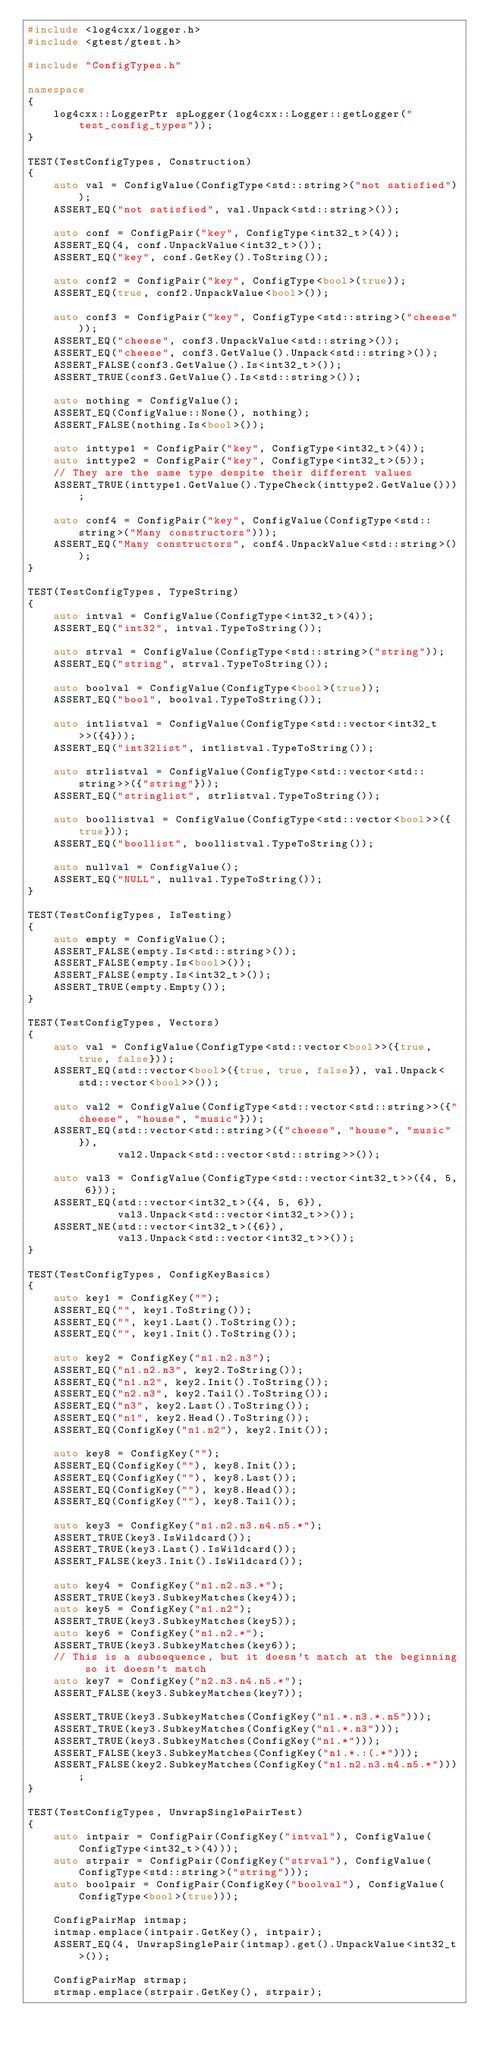<code> <loc_0><loc_0><loc_500><loc_500><_C++_>#include <log4cxx/logger.h>
#include <gtest/gtest.h>

#include "ConfigTypes.h"

namespace
{
    log4cxx::LoggerPtr spLogger(log4cxx::Logger::getLogger("test_config_types"));
}

TEST(TestConfigTypes, Construction)
{
    auto val = ConfigValue(ConfigType<std::string>("not satisfied"));
    ASSERT_EQ("not satisfied", val.Unpack<std::string>());

    auto conf = ConfigPair("key", ConfigType<int32_t>(4));
    ASSERT_EQ(4, conf.UnpackValue<int32_t>());
    ASSERT_EQ("key", conf.GetKey().ToString());

    auto conf2 = ConfigPair("key", ConfigType<bool>(true));
    ASSERT_EQ(true, conf2.UnpackValue<bool>());

    auto conf3 = ConfigPair("key", ConfigType<std::string>("cheese"));
    ASSERT_EQ("cheese", conf3.UnpackValue<std::string>());
    ASSERT_EQ("cheese", conf3.GetValue().Unpack<std::string>());
    ASSERT_FALSE(conf3.GetValue().Is<int32_t>());
    ASSERT_TRUE(conf3.GetValue().Is<std::string>());

    auto nothing = ConfigValue();
    ASSERT_EQ(ConfigValue::None(), nothing);
    ASSERT_FALSE(nothing.Is<bool>());

    auto inttype1 = ConfigPair("key", ConfigType<int32_t>(4));
    auto inttype2 = ConfigPair("key", ConfigType<int32_t>(5));
    // They are the same type despite their different values
    ASSERT_TRUE(inttype1.GetValue().TypeCheck(inttype2.GetValue()));

    auto conf4 = ConfigPair("key", ConfigValue(ConfigType<std::string>("Many constructors")));
    ASSERT_EQ("Many constructors", conf4.UnpackValue<std::string>());
}

TEST(TestConfigTypes, TypeString)
{
    auto intval = ConfigValue(ConfigType<int32_t>(4));
    ASSERT_EQ("int32", intval.TypeToString());

    auto strval = ConfigValue(ConfigType<std::string>("string"));
    ASSERT_EQ("string", strval.TypeToString());

    auto boolval = ConfigValue(ConfigType<bool>(true));
    ASSERT_EQ("bool", boolval.TypeToString());

    auto intlistval = ConfigValue(ConfigType<std::vector<int32_t>>({4}));
    ASSERT_EQ("int32list", intlistval.TypeToString());

    auto strlistval = ConfigValue(ConfigType<std::vector<std::string>>({"string"}));
    ASSERT_EQ("stringlist", strlistval.TypeToString());

    auto boollistval = ConfigValue(ConfigType<std::vector<bool>>({true}));
    ASSERT_EQ("boollist", boollistval.TypeToString());

    auto nullval = ConfigValue();
    ASSERT_EQ("NULL", nullval.TypeToString());
}

TEST(TestConfigTypes, IsTesting)
{
    auto empty = ConfigValue();
    ASSERT_FALSE(empty.Is<std::string>());
    ASSERT_FALSE(empty.Is<bool>());
    ASSERT_FALSE(empty.Is<int32_t>());
    ASSERT_TRUE(empty.Empty());
}

TEST(TestConfigTypes, Vectors)
{
    auto val = ConfigValue(ConfigType<std::vector<bool>>({true, true, false}));
    ASSERT_EQ(std::vector<bool>({true, true, false}), val.Unpack<std::vector<bool>>());

    auto val2 = ConfigValue(ConfigType<std::vector<std::string>>({"cheese", "house", "music"}));
    ASSERT_EQ(std::vector<std::string>({"cheese", "house", "music"}),
              val2.Unpack<std::vector<std::string>>());

    auto val3 = ConfigValue(ConfigType<std::vector<int32_t>>({4, 5, 6}));
    ASSERT_EQ(std::vector<int32_t>({4, 5, 6}),
              val3.Unpack<std::vector<int32_t>>());
    ASSERT_NE(std::vector<int32_t>({6}),
              val3.Unpack<std::vector<int32_t>>());
}

TEST(TestConfigTypes, ConfigKeyBasics)
{
    auto key1 = ConfigKey("");
    ASSERT_EQ("", key1.ToString());
    ASSERT_EQ("", key1.Last().ToString());
    ASSERT_EQ("", key1.Init().ToString());

    auto key2 = ConfigKey("n1.n2.n3");
    ASSERT_EQ("n1.n2.n3", key2.ToString());
    ASSERT_EQ("n1.n2", key2.Init().ToString());
    ASSERT_EQ("n2.n3", key2.Tail().ToString());
    ASSERT_EQ("n3", key2.Last().ToString());
    ASSERT_EQ("n1", key2.Head().ToString());
    ASSERT_EQ(ConfigKey("n1.n2"), key2.Init());

    auto key8 = ConfigKey("");
    ASSERT_EQ(ConfigKey(""), key8.Init());
    ASSERT_EQ(ConfigKey(""), key8.Last());
    ASSERT_EQ(ConfigKey(""), key8.Head());
    ASSERT_EQ(ConfigKey(""), key8.Tail());

    auto key3 = ConfigKey("n1.n2.n3.n4.n5.*");
    ASSERT_TRUE(key3.IsWildcard());
    ASSERT_TRUE(key3.Last().IsWildcard());
    ASSERT_FALSE(key3.Init().IsWildcard());

    auto key4 = ConfigKey("n1.n2.n3.*");
    ASSERT_TRUE(key3.SubkeyMatches(key4));
    auto key5 = ConfigKey("n1.n2");
    ASSERT_TRUE(key3.SubkeyMatches(key5));
    auto key6 = ConfigKey("n1.n2.*");
    ASSERT_TRUE(key3.SubkeyMatches(key6));
    // This is a subsequence, but it doesn't match at the beginning so it doesn't match
    auto key7 = ConfigKey("n2.n3.n4.n5.*");
    ASSERT_FALSE(key3.SubkeyMatches(key7));

    ASSERT_TRUE(key3.SubkeyMatches(ConfigKey("n1.*.n3.*.n5")));
    ASSERT_TRUE(key3.SubkeyMatches(ConfigKey("n1.*.n3")));
    ASSERT_TRUE(key3.SubkeyMatches(ConfigKey("n1.*")));
    ASSERT_FALSE(key3.SubkeyMatches(ConfigKey("n1.*.:(.*")));
    ASSERT_FALSE(key2.SubkeyMatches(ConfigKey("n1.n2.n3.n4.n5.*")));
}

TEST(TestConfigTypes, UnwrapSinglePairTest)
{
    auto intpair = ConfigPair(ConfigKey("intval"), ConfigValue(ConfigType<int32_t>(4)));
    auto strpair = ConfigPair(ConfigKey("strval"), ConfigValue(ConfigType<std::string>("string")));
    auto boolpair = ConfigPair(ConfigKey("boolval"), ConfigValue(ConfigType<bool>(true)));

    ConfigPairMap intmap;
    intmap.emplace(intpair.GetKey(), intpair);
    ASSERT_EQ(4, UnwrapSinglePair(intmap).get().UnpackValue<int32_t>());

    ConfigPairMap strmap;
    strmap.emplace(strpair.GetKey(), strpair);</code> 